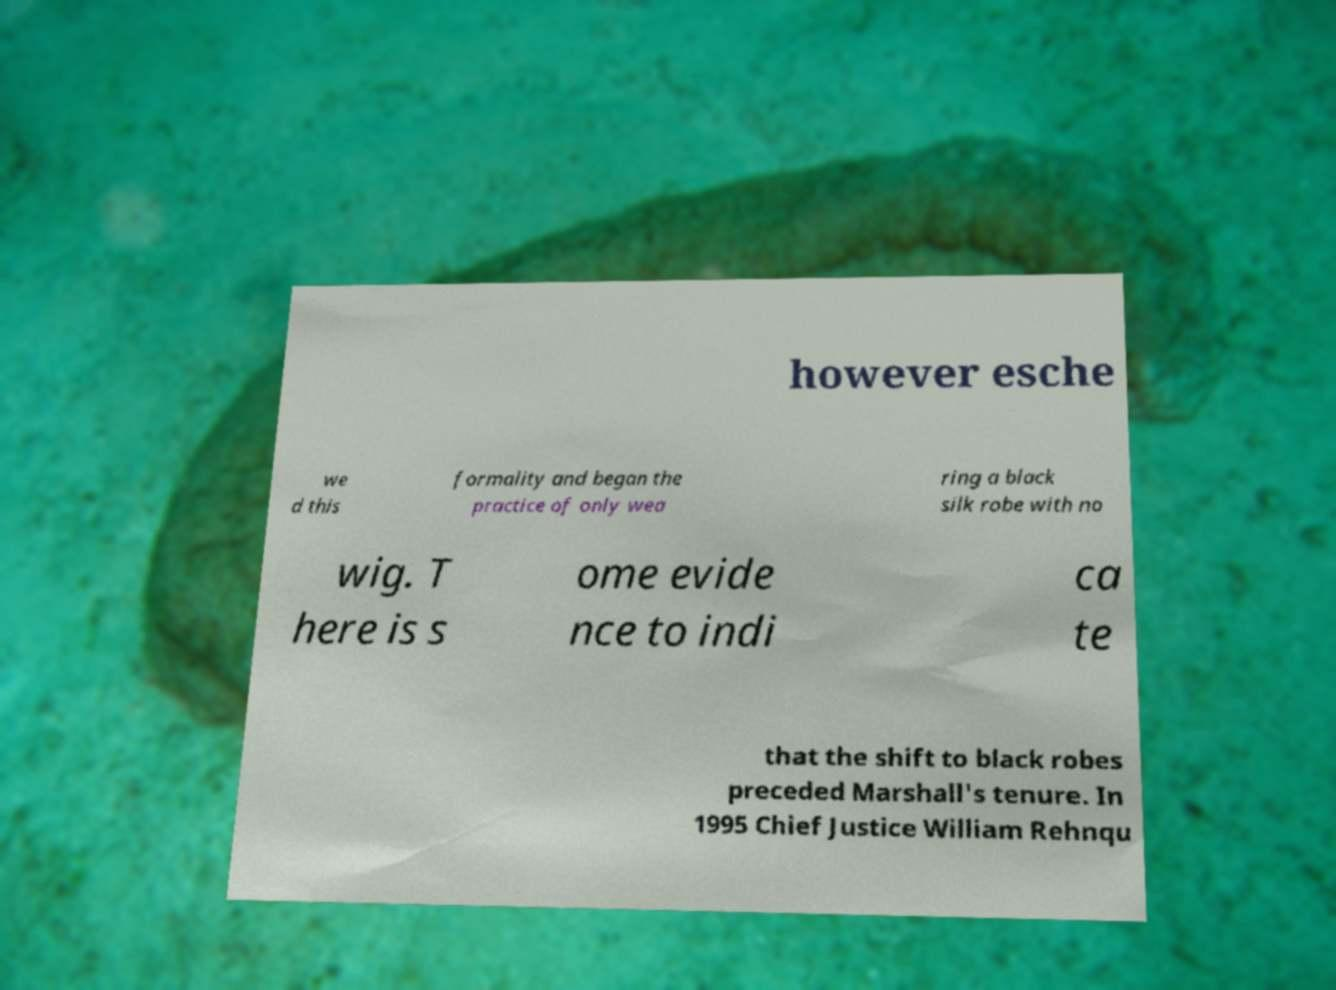Can you read and provide the text displayed in the image?This photo seems to have some interesting text. Can you extract and type it out for me? however esche we d this formality and began the practice of only wea ring a black silk robe with no wig. T here is s ome evide nce to indi ca te that the shift to black robes preceded Marshall's tenure. In 1995 Chief Justice William Rehnqu 